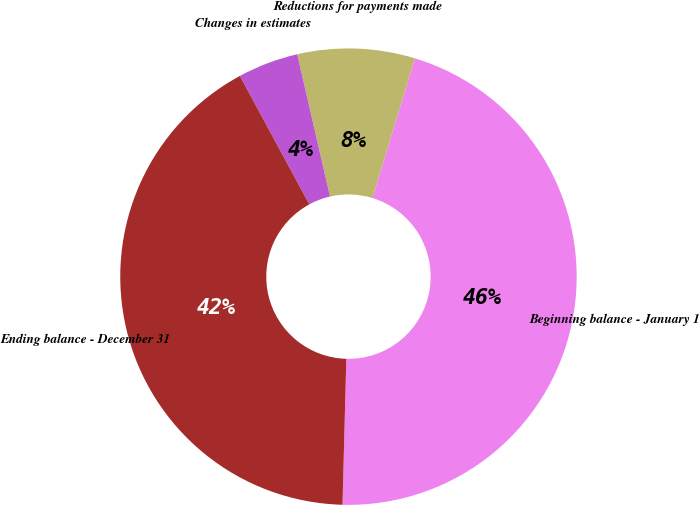Convert chart. <chart><loc_0><loc_0><loc_500><loc_500><pie_chart><fcel>Beginning balance - January 1<fcel>Reductions for payments made<fcel>Changes in estimates<fcel>Ending balance - December 31<nl><fcel>45.71%<fcel>8.31%<fcel>4.29%<fcel>41.69%<nl></chart> 